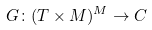Convert formula to latex. <formula><loc_0><loc_0><loc_500><loc_500>G \colon ( T \times M ) ^ { M } \rightarrow C</formula> 